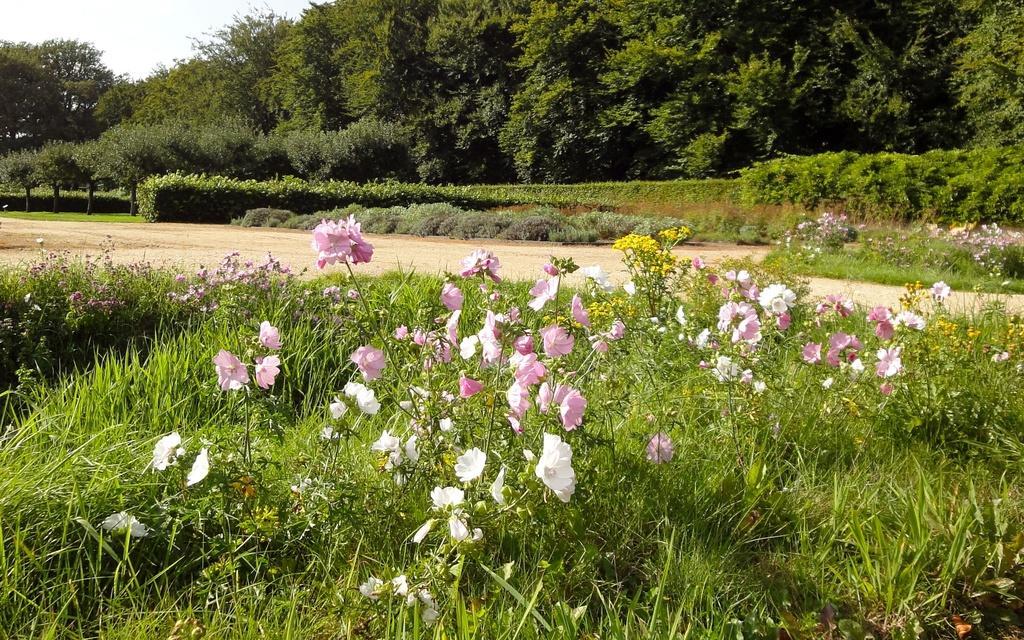Could you give a brief overview of what you see in this image? In this image we can see flowers, plants, trees and sky. 